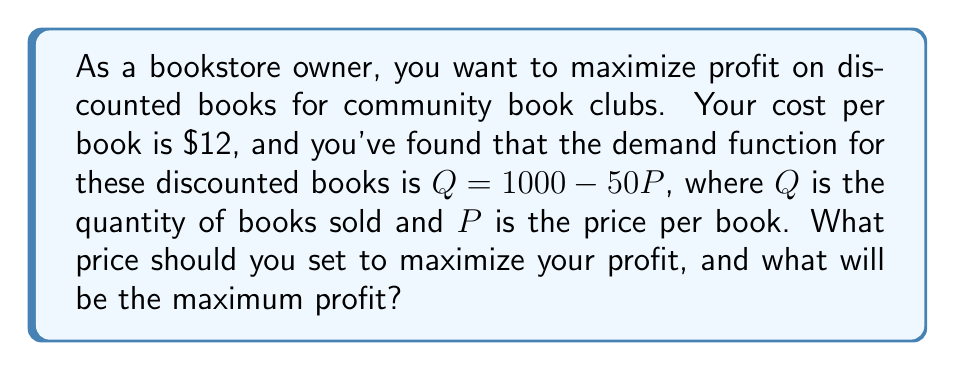Solve this math problem. To solve this problem, we'll follow these steps:

1) First, let's define our profit function. Profit is revenue minus cost:
   $\text{Profit} = \text{Revenue} - \text{Cost}$

2) Revenue is price times quantity: $R = PQ$
   Cost is the cost per book times quantity: $C = 12Q$

3) Substituting the demand function $Q = 1000 - 50P$, we get:
   $\text{Profit} = P(1000 - 50P) - 12(1000 - 50P)$

4) Simplify:
   $\text{Profit} = 1000P - 50P^2 - 12000 + 600P$
   $\text{Profit} = -50P^2 + 1600P - 12000$

5) To find the maximum profit, we need to find the vertex of this quadratic function. We can do this by finding where the derivative equals zero:

   $\frac{d(\text{Profit})}{dP} = -100P + 1600$

6) Set this equal to zero and solve for P:
   $-100P + 1600 = 0$
   $-100P = -1600$
   $P = 16$

7) To confirm this is a maximum (not a minimum), we can check that the second derivative is negative:
   $\frac{d^2(\text{Profit})}{dP^2} = -100$, which is indeed negative.

8) Now that we know the optimal price is $16, we can calculate the maximum profit:
   $\text{Profit} = -50(16)^2 + 1600(16) - 12000$
   $= -12800 + 25600 - 12000$
   $= 800$
Answer: The optimal price to maximize profit is $16 per book, and the maximum profit is $800. 